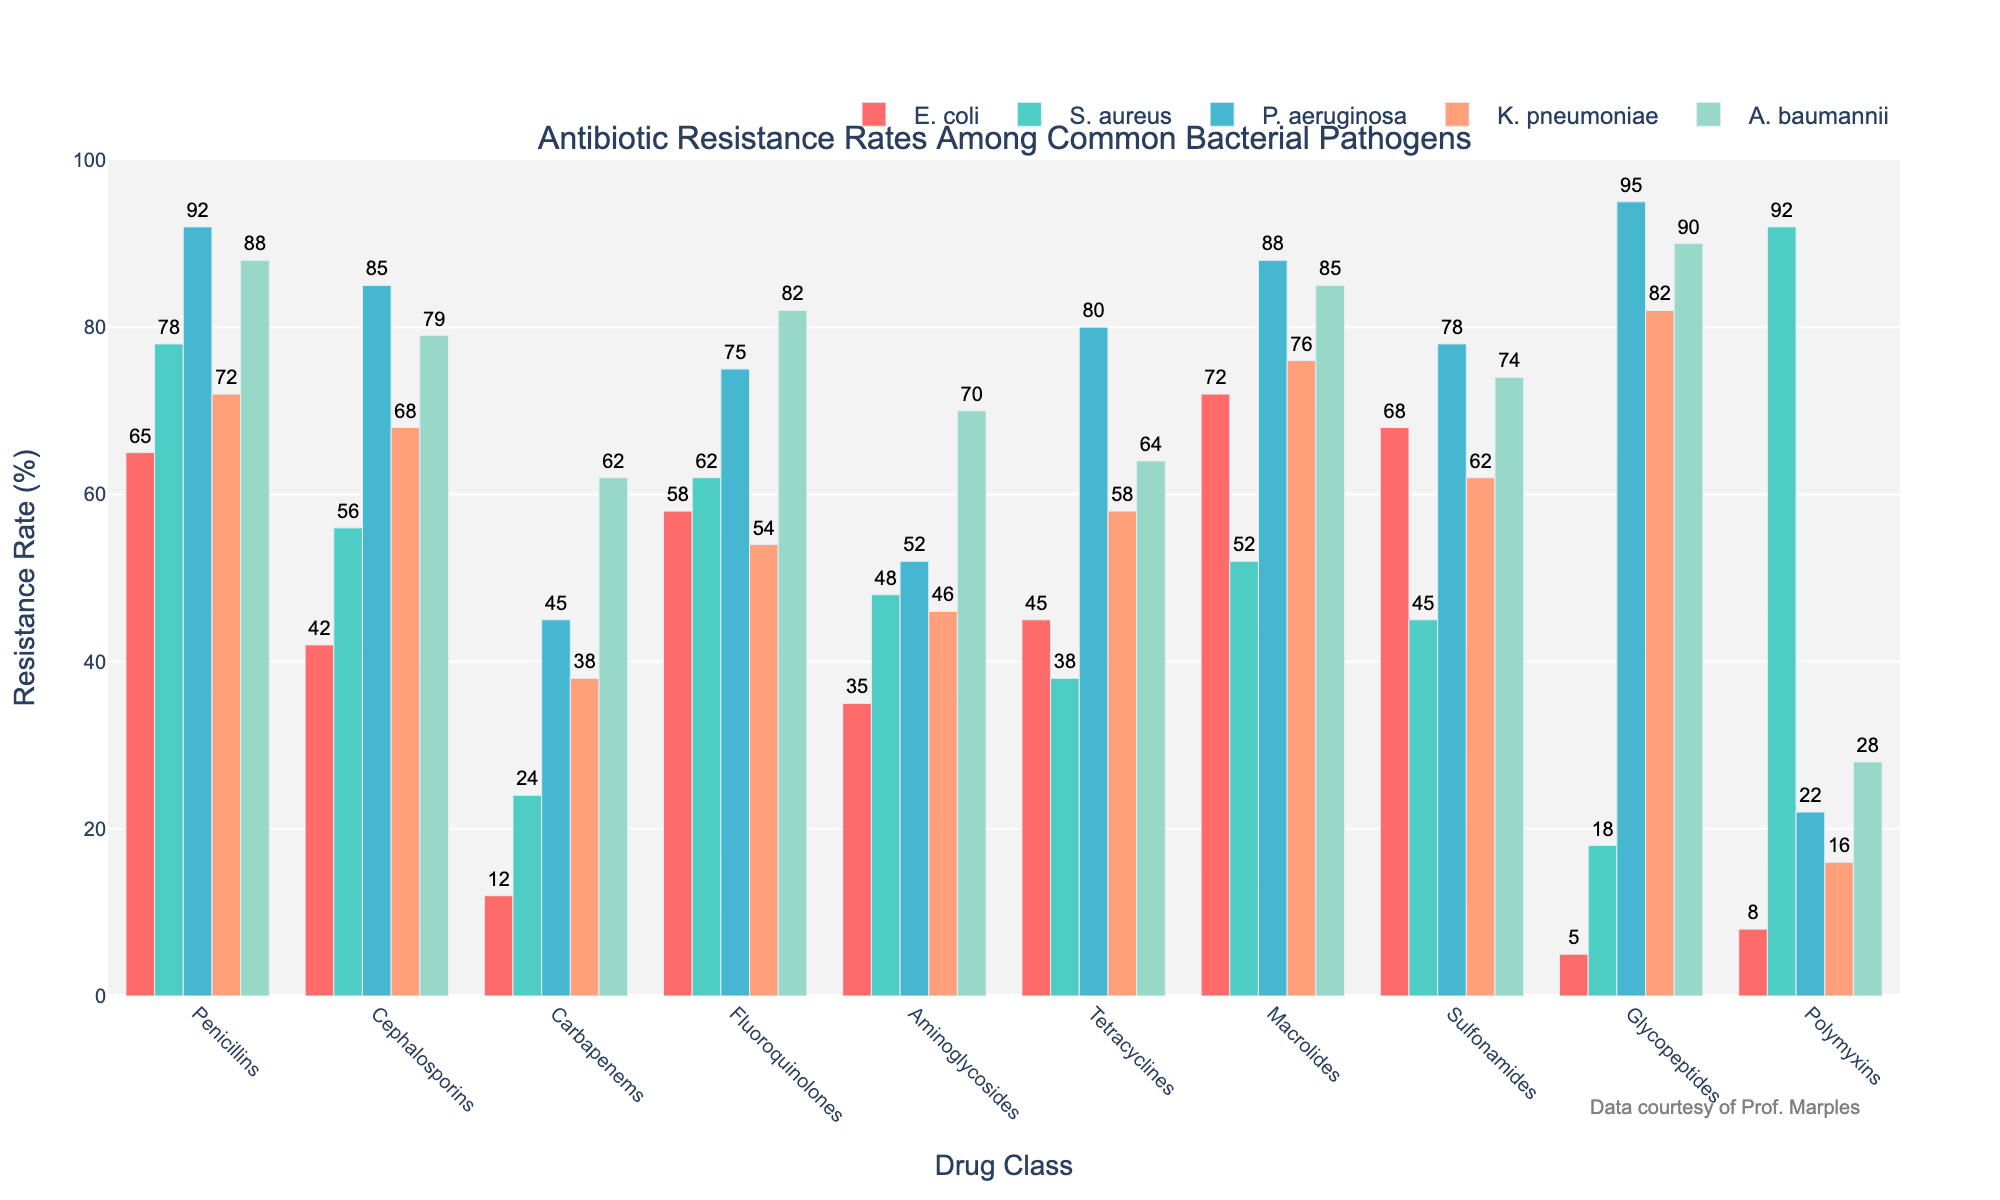What is the antibiotic resistance rate of E. coli to Cephalosporins? Look at the bar representing E. coli for the Cephalosporins drug class. The height of the bar indicates the resistance rate.
Answer: 42 Which bacterial pathogen shows the highest resistance rate to Glycopeptides? Compare the heights of the Glycopeptides bars for all bacterial pathogens. The tallest bar indicates the highest resistance rate.
Answer: P. aeruginosa Among P. aeruginosa and A. baumannii, which has a lower resistance rate to Carbapenems and by how much? Check the height of the Carbapenems bars for both P. aeruginosa and A. baumannii. Subtract the resistance rate of A. baumannii from P. aeruginosa.
Answer: P. aeruginosa, by 17 What is the average resistance rate of K. pneumoniae across all drug classes? Add the resistance rates for K. pneumoniae across all drug classes and divide by the number of classes (10).
Answer: 62.4 Which drug class shows the smallest resistance rate difference between S. aureus and K. pneumoniae? For each drug class, compute the absolute difference in resistance rates between S. aureus and K. pneumoniae and identify the smallest one.
Answer: Carbapenems Which bacterial pathogen shows a resistance rate of 75% to Fluoroquinolones? Identify the bar with a height of 75% in the Fluoroquinolones category and note the corresponding bacterial pathogen.
Answer: P. aeruginosa Sum the resistance rates of E. coli to Penicillins and Tetracyclines. Add the resistance rates of E. coli to Penicillins (65) and Tetracyclines (45).
Answer: 110 Between E. coli and S. aureus, which one has a higher average resistance rate across all drug classes and what is the average for each? Calculate the average resistance rate by adding the values and dividing by 10 for both E. coli and S. aureus, then compare the averages.
Answer: E. coli: 41, S. aureus: 51 What is the total resistance rate of A. baumannii to all drug classes combined? Sum the resistance rates of A. baumannii for each drug class.
Answer: 748 